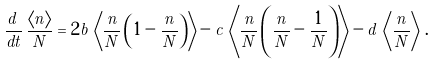<formula> <loc_0><loc_0><loc_500><loc_500>\frac { d \, } { d t } \, \frac { \langle n \rangle } { N } = 2 \tilde { b } \, \left \langle \frac { n } { N } \left ( 1 - \frac { n } { N } \right ) \right \rangle - \tilde { c } \, \left \langle \frac { n } { N } \left ( \frac { n } { N } - \frac { 1 } { N } \right ) \right \rangle - \tilde { d } \, \left \langle \frac { n } { N } \right \rangle \, .</formula> 